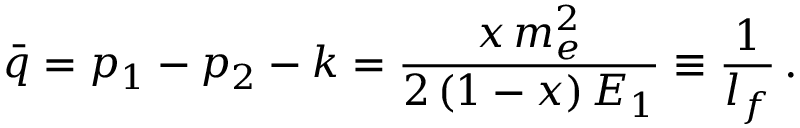<formula> <loc_0><loc_0><loc_500><loc_500>\bar { q } = p _ { 1 } - p _ { 2 } - k = \frac { x \, m _ { e } ^ { 2 } } { 2 \, ( 1 - x ) \, E _ { 1 } } \equiv \frac { 1 } { l _ { f } } \, .</formula> 